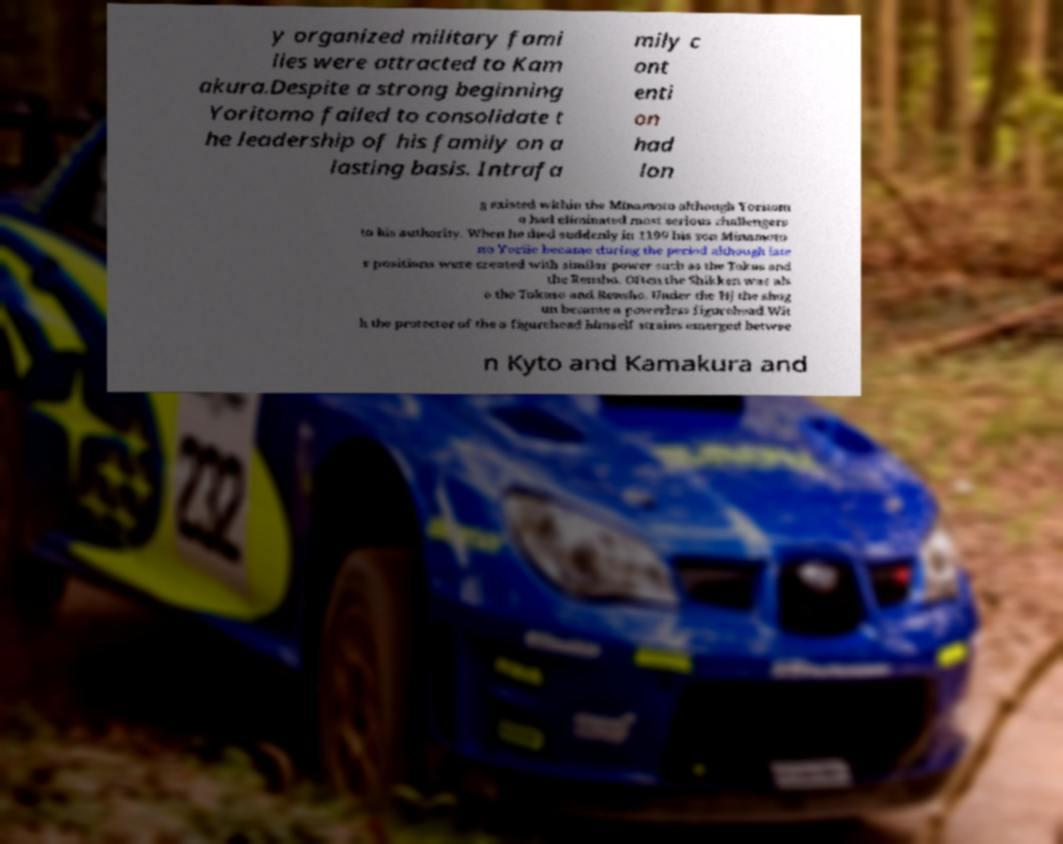Could you extract and type out the text from this image? y organized military fami lies were attracted to Kam akura.Despite a strong beginning Yoritomo failed to consolidate t he leadership of his family on a lasting basis. Intrafa mily c ont enti on had lon g existed within the Minamoto although Yoritom o had eliminated most serious challengers to his authority. When he died suddenly in 1199 his son Minamoto no Yoriie became during the period although late r positions were created with similar power such as the Tokus and the Rensho. Often the Shikken was als o the Tokuso and Rensho. Under the Hj the shog un became a powerless figurehead.Wit h the protector of the a figurehead himself strains emerged betwee n Kyto and Kamakura and 